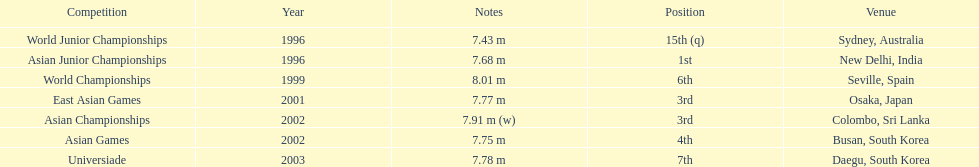What is the number of competitions that have been competed in? 7. 